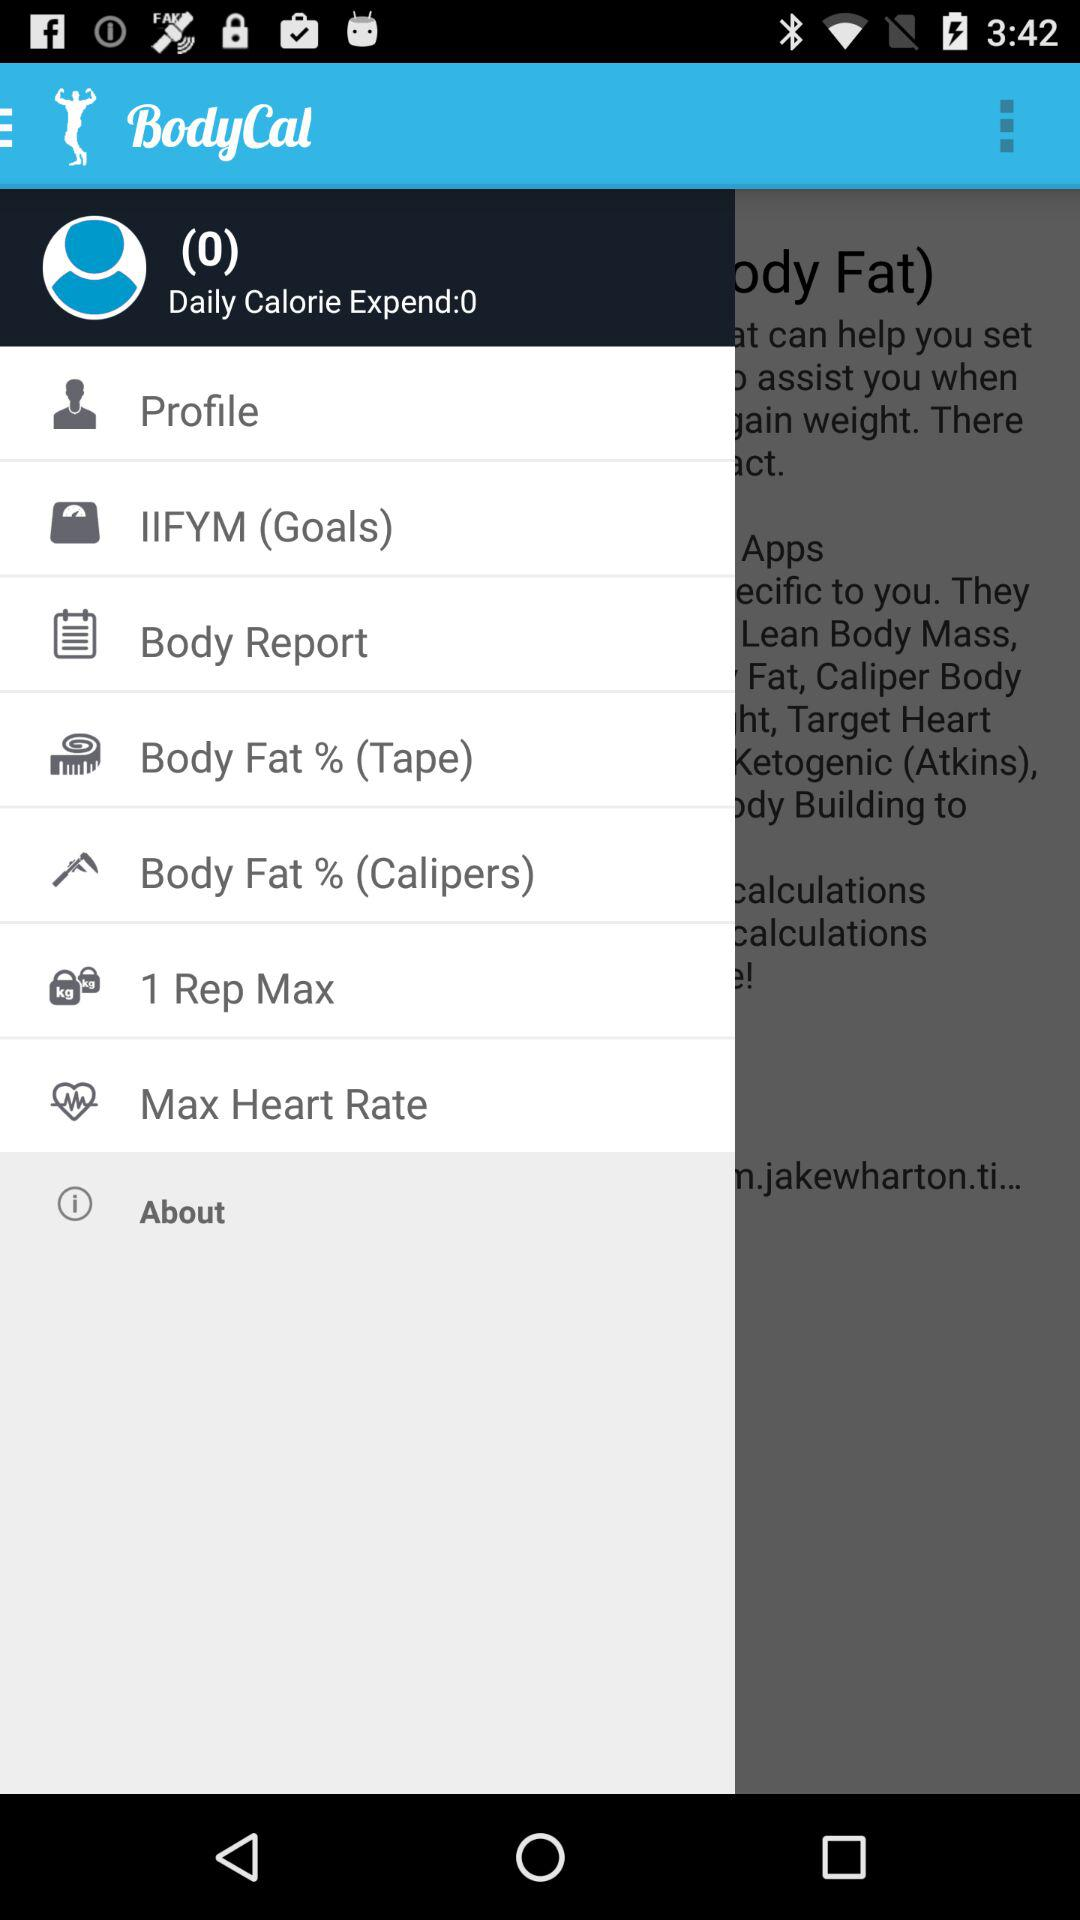How much body fat % is listed?
When the provided information is insufficient, respond with <no answer>. <no answer> 